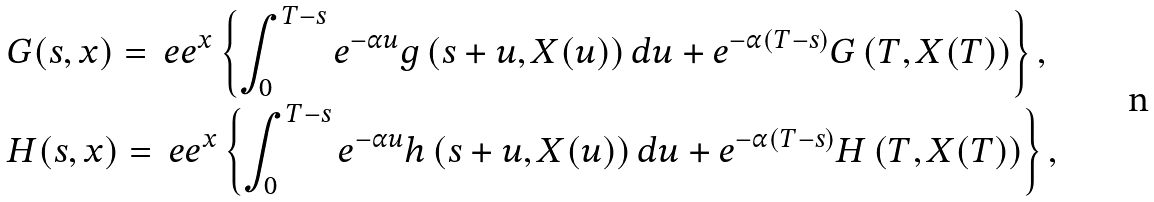<formula> <loc_0><loc_0><loc_500><loc_500>& G ( s , x ) = \ e e ^ { x } \left \{ \int _ { 0 } ^ { T - s } e ^ { - \alpha u } g \left ( s + u , X ( u ) \right ) d u + e ^ { - \alpha ( T - s ) } G \left ( T , X ( T ) \right ) \right \} , \\ & H ( s , x ) = \ e e ^ { x } \left \{ \int _ { 0 } ^ { T - s } e ^ { - \alpha u } h \left ( s + u , X ( u ) \right ) d u + e ^ { - \alpha ( T - s ) } H \left ( T , X ( T ) \right ) \right \} ,</formula> 